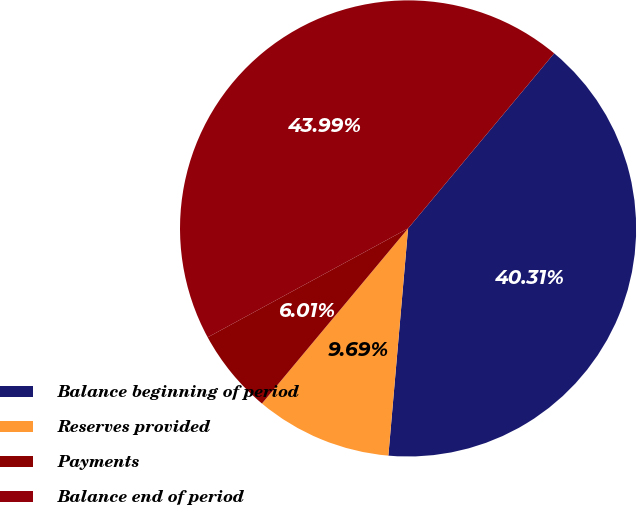Convert chart. <chart><loc_0><loc_0><loc_500><loc_500><pie_chart><fcel>Balance beginning of period<fcel>Reserves provided<fcel>Payments<fcel>Balance end of period<nl><fcel>40.31%<fcel>9.69%<fcel>6.01%<fcel>43.99%<nl></chart> 